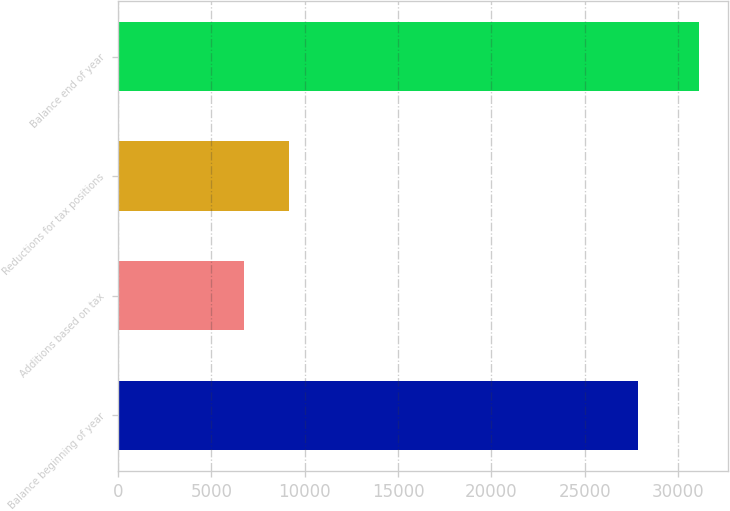Convert chart. <chart><loc_0><loc_0><loc_500><loc_500><bar_chart><fcel>Balance beginning of year<fcel>Additions based on tax<fcel>Reductions for tax positions<fcel>Balance end of year<nl><fcel>27825<fcel>6731<fcel>9170.9<fcel>31130<nl></chart> 